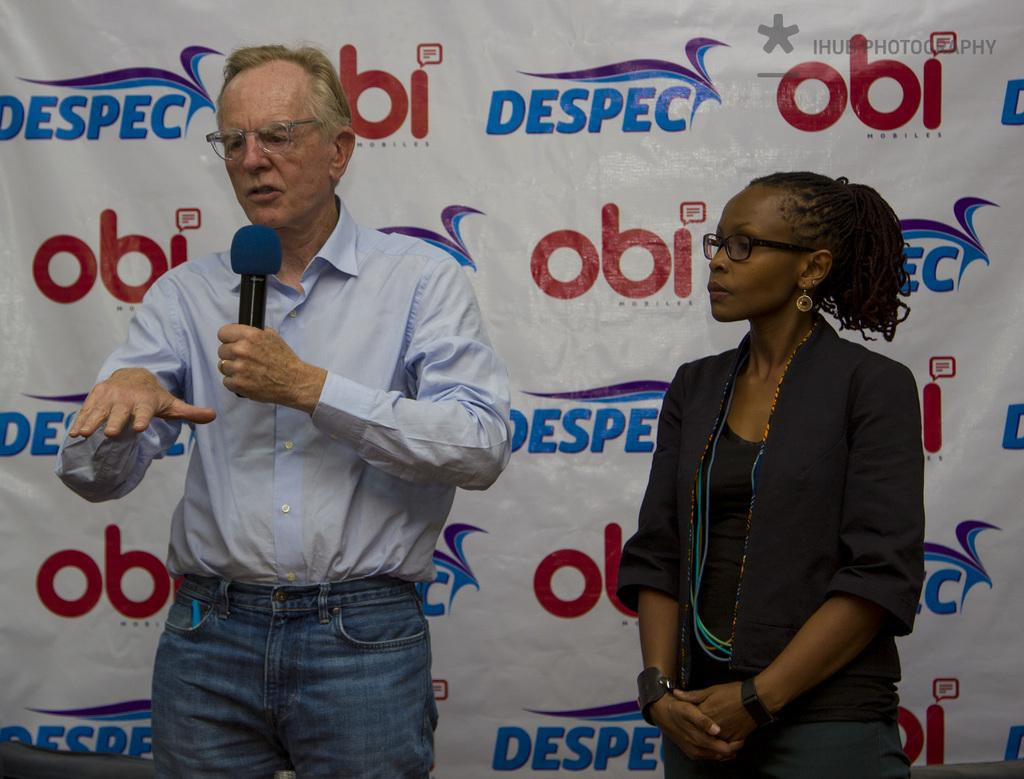How many people are in the image? There are two people in the foreground of the image. What can be seen in the background of the image? There is a banner with text in the background of the image. How many pizzas are being served by the doctor in the image? There are no pizzas or doctors present in the image. What color is the ladybug on the banner in the image? There is no ladybug on the banner or in the image. 